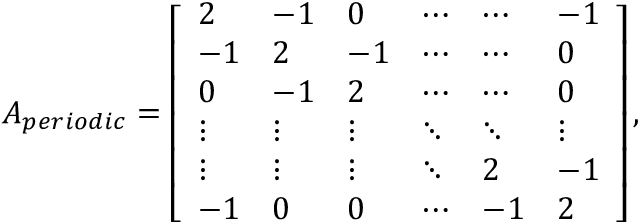Convert formula to latex. <formula><loc_0><loc_0><loc_500><loc_500>A _ { p e r i o d i c } = \left [ \begin{array} { l l l l l l } { 2 } & { - 1 } & { 0 } & { \cdots } & { \cdots } & { - 1 } \\ { - 1 } & { 2 } & { - 1 } & { \cdots } & { \cdots } & { 0 } \\ { 0 } & { - 1 } & { 2 } & { \cdots } & { \cdots } & { 0 } \\ { \vdots } & { \vdots } & { \vdots } & { \ddots } & { \ddots } & { \vdots } \\ { \vdots } & { \vdots } & { \vdots } & { \ddots } & { 2 } & { - 1 } \\ { - 1 } & { 0 } & { 0 } & { \cdots } & { - 1 } & { 2 } \end{array} \right ] ,</formula> 